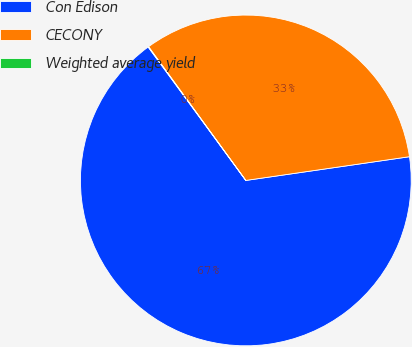<chart> <loc_0><loc_0><loc_500><loc_500><pie_chart><fcel>Con Edison<fcel>CECONY<fcel>Weighted average yield<nl><fcel>67.23%<fcel>32.71%<fcel>0.05%<nl></chart> 